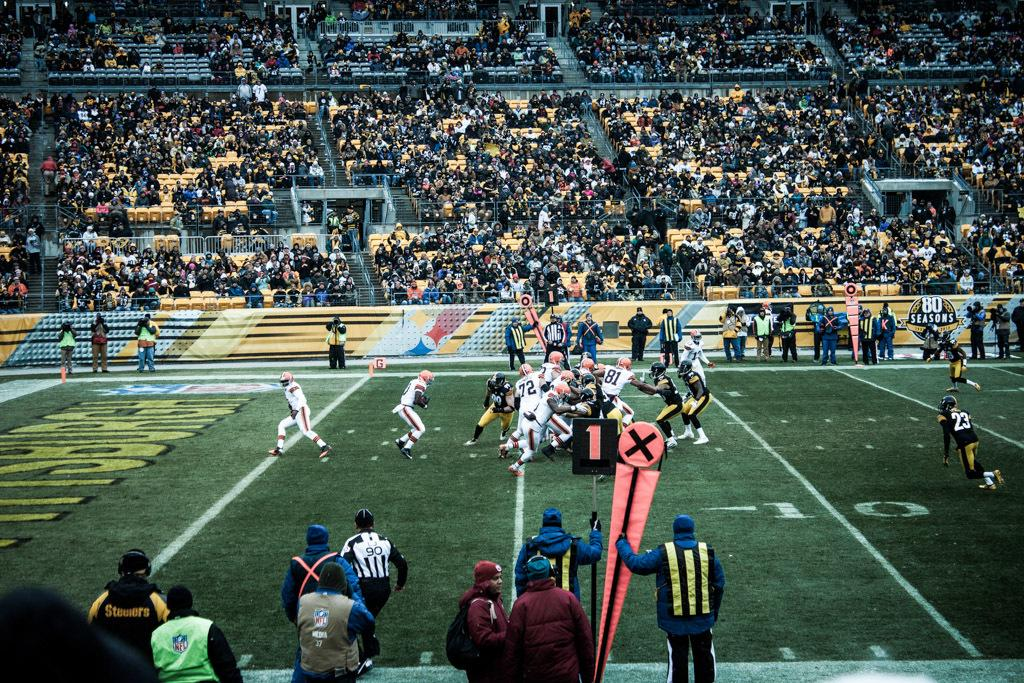Provide a one-sentence caption for the provided image. A football game where there are many players in the middle of the field they are at the 8 yard line. 